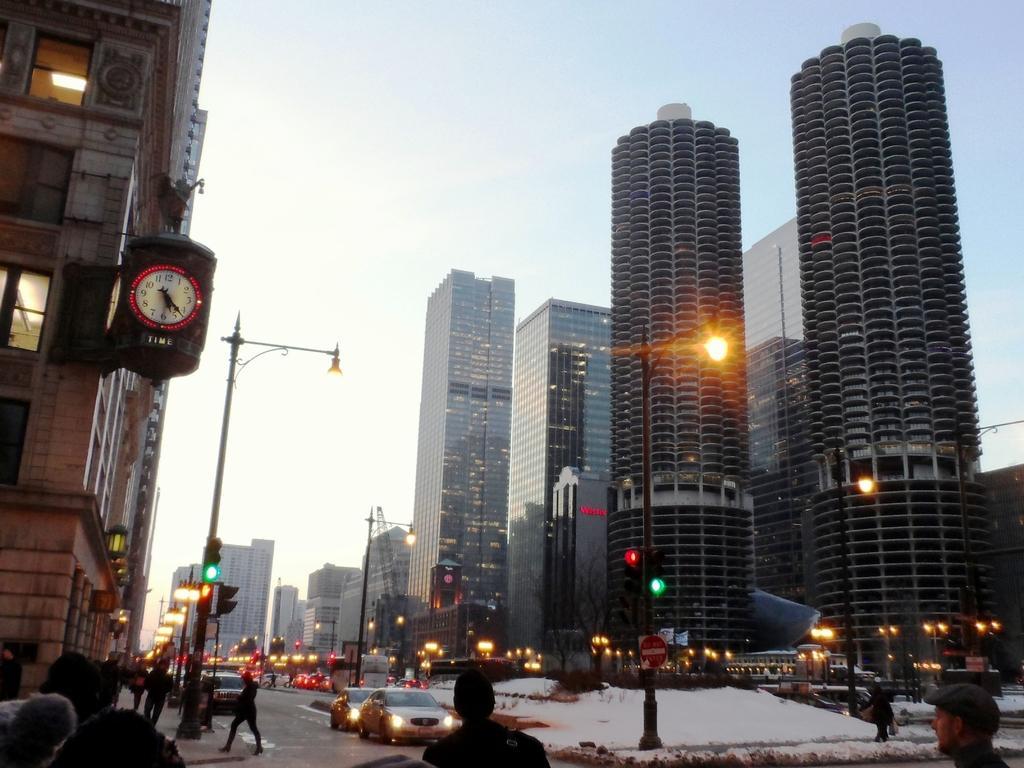Could you give a brief overview of what you see in this image? On the right and left side of the image there are few buildings, in front of the buildings there are some utility poles. In the middle of the building there is a road. On the road there are few vehicles are passing and some people are walking on the pavement. In the background there is a sky. 